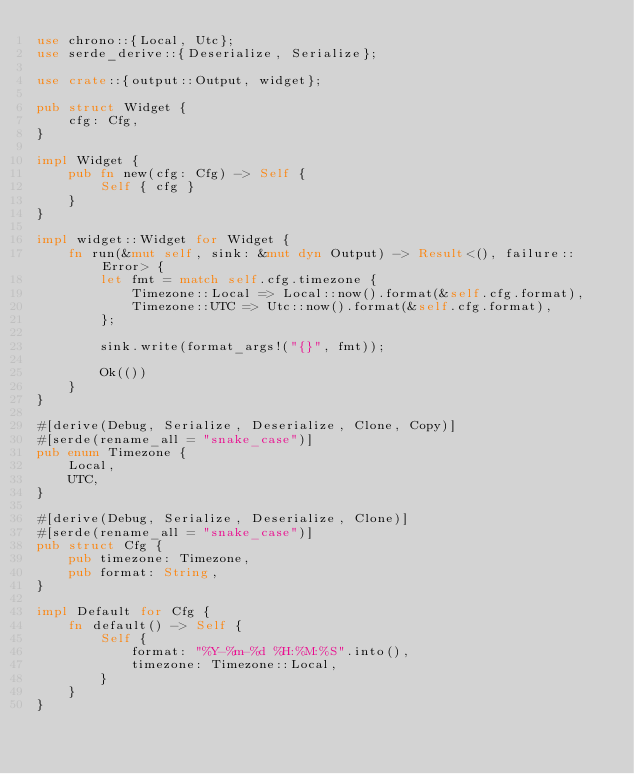<code> <loc_0><loc_0><loc_500><loc_500><_Rust_>use chrono::{Local, Utc};
use serde_derive::{Deserialize, Serialize};

use crate::{output::Output, widget};

pub struct Widget {
    cfg: Cfg,
}

impl Widget {
    pub fn new(cfg: Cfg) -> Self {
        Self { cfg }
    }
}

impl widget::Widget for Widget {
    fn run(&mut self, sink: &mut dyn Output) -> Result<(), failure::Error> {
        let fmt = match self.cfg.timezone {
            Timezone::Local => Local::now().format(&self.cfg.format),
            Timezone::UTC => Utc::now().format(&self.cfg.format),
        };

        sink.write(format_args!("{}", fmt));

        Ok(())
    }
}

#[derive(Debug, Serialize, Deserialize, Clone, Copy)]
#[serde(rename_all = "snake_case")]
pub enum Timezone {
    Local,
    UTC,
}

#[derive(Debug, Serialize, Deserialize, Clone)]
#[serde(rename_all = "snake_case")]
pub struct Cfg {
    pub timezone: Timezone,
    pub format: String,
}

impl Default for Cfg {
    fn default() -> Self {
        Self {
            format: "%Y-%m-%d %H:%M:%S".into(),
            timezone: Timezone::Local,
        }
    }
}
</code> 